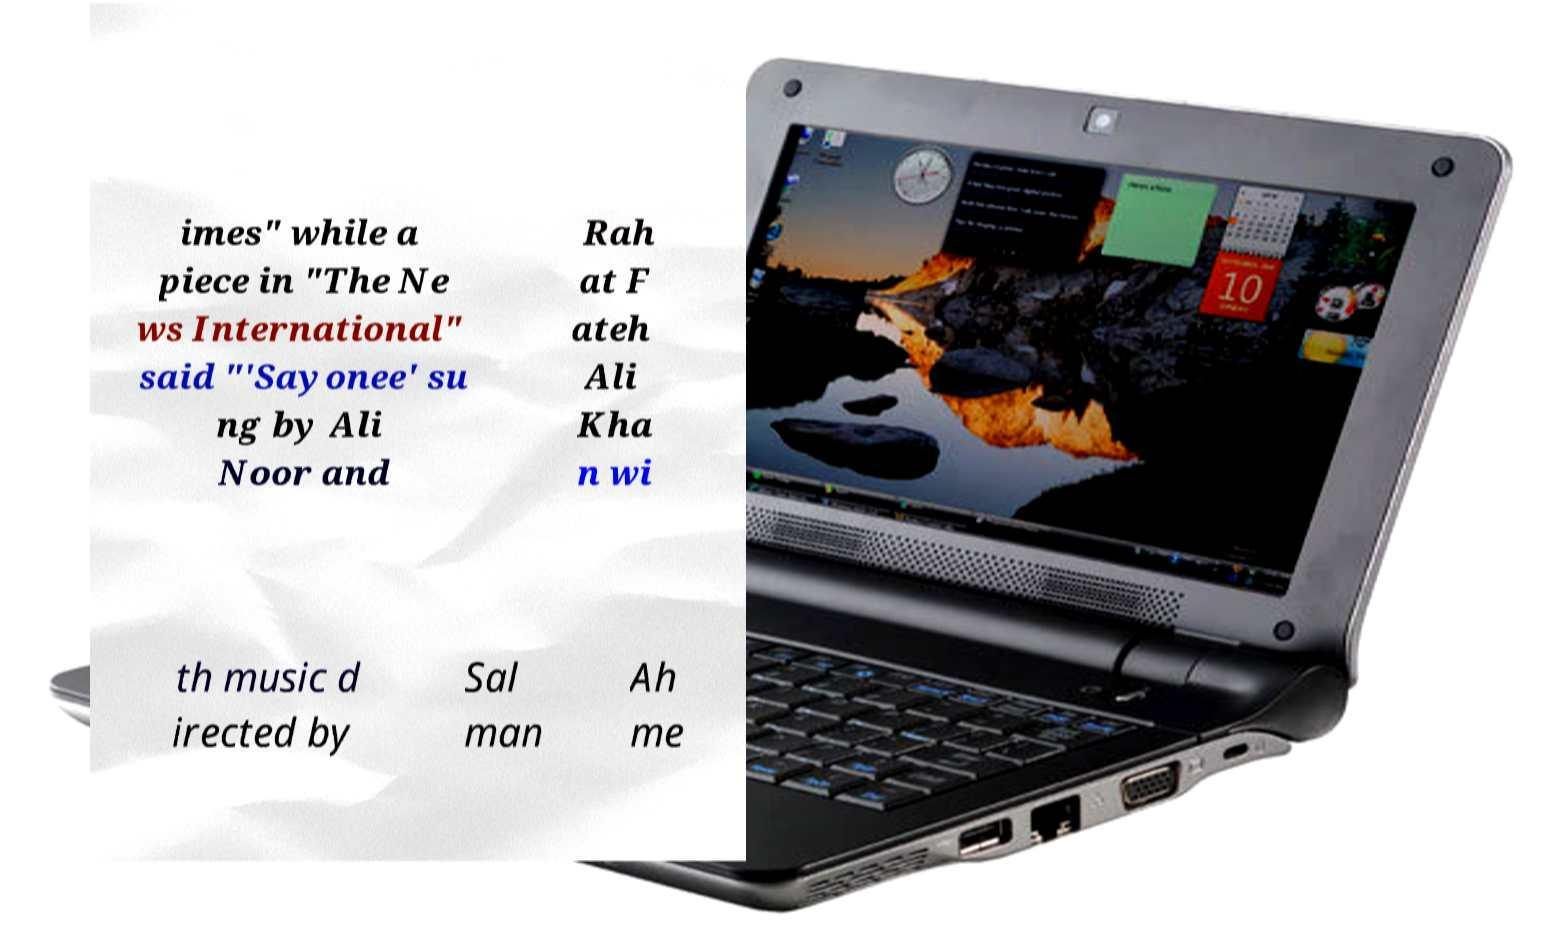What messages or text are displayed in this image? I need them in a readable, typed format. imes" while a piece in "The Ne ws International" said "'Sayonee' su ng by Ali Noor and Rah at F ateh Ali Kha n wi th music d irected by Sal man Ah me 